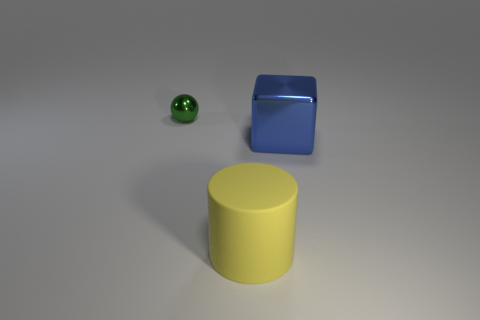Is there any other thing that has the same size as the green ball?
Offer a very short reply. No. Is there any other thing that has the same material as the large yellow thing?
Your answer should be very brief. No. There is a cylinder that is the same size as the metallic cube; what is its color?
Your answer should be very brief. Yellow. How many objects are either things behind the blue metallic object or objects that are in front of the small green ball?
Your response must be concise. 3. How many things are either green shiny objects or cyan rubber cubes?
Your answer should be very brief. 1. There is a object that is behind the yellow cylinder and to the right of the green sphere; what size is it?
Provide a succinct answer. Large. How many large blue objects have the same material as the tiny thing?
Provide a short and direct response. 1. What is the color of the small ball that is made of the same material as the large blue cube?
Offer a very short reply. Green. There is a metal thing that is in front of the green sphere; does it have the same color as the small ball?
Offer a terse response. No. What is the large thing on the left side of the shiny cube made of?
Provide a succinct answer. Rubber. 